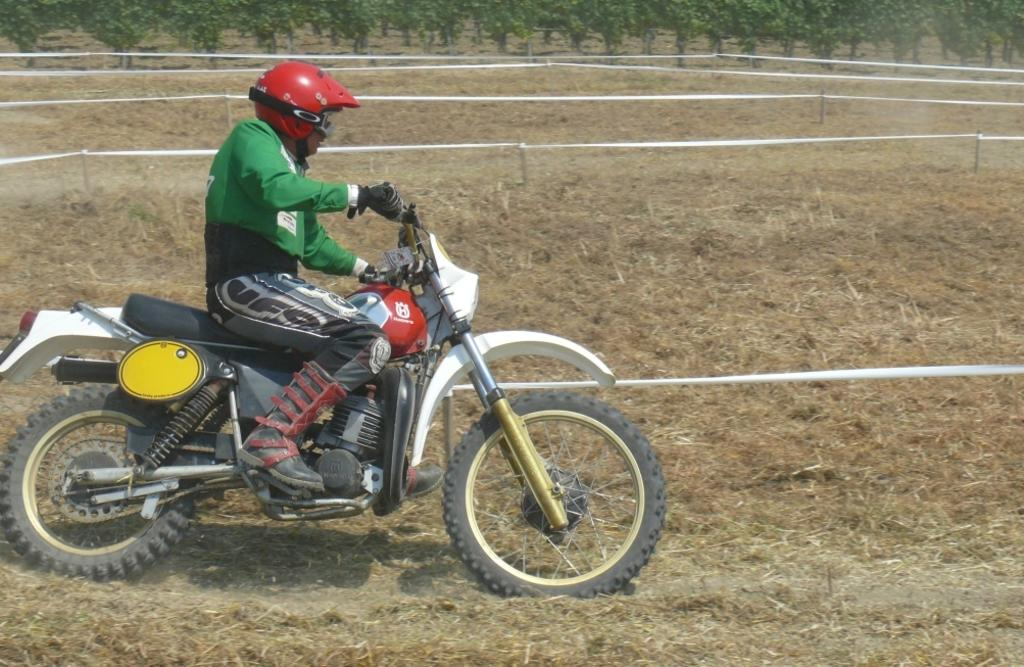What is the man in the image doing? The man is riding a motorcycle in the image. Where is the man located in the image? The man is on the bottom left side of the image. What is behind the man in the image? There is a fencing behind the man. What type of vegetation is present in the image? There is grass in the image. What can be seen in the background of the image? There are trees at the top of the image. Is the man wearing a mask while riding the motorcycle in the image? There is no mention of a mask in the image, so we cannot determine if the man is wearing one. 